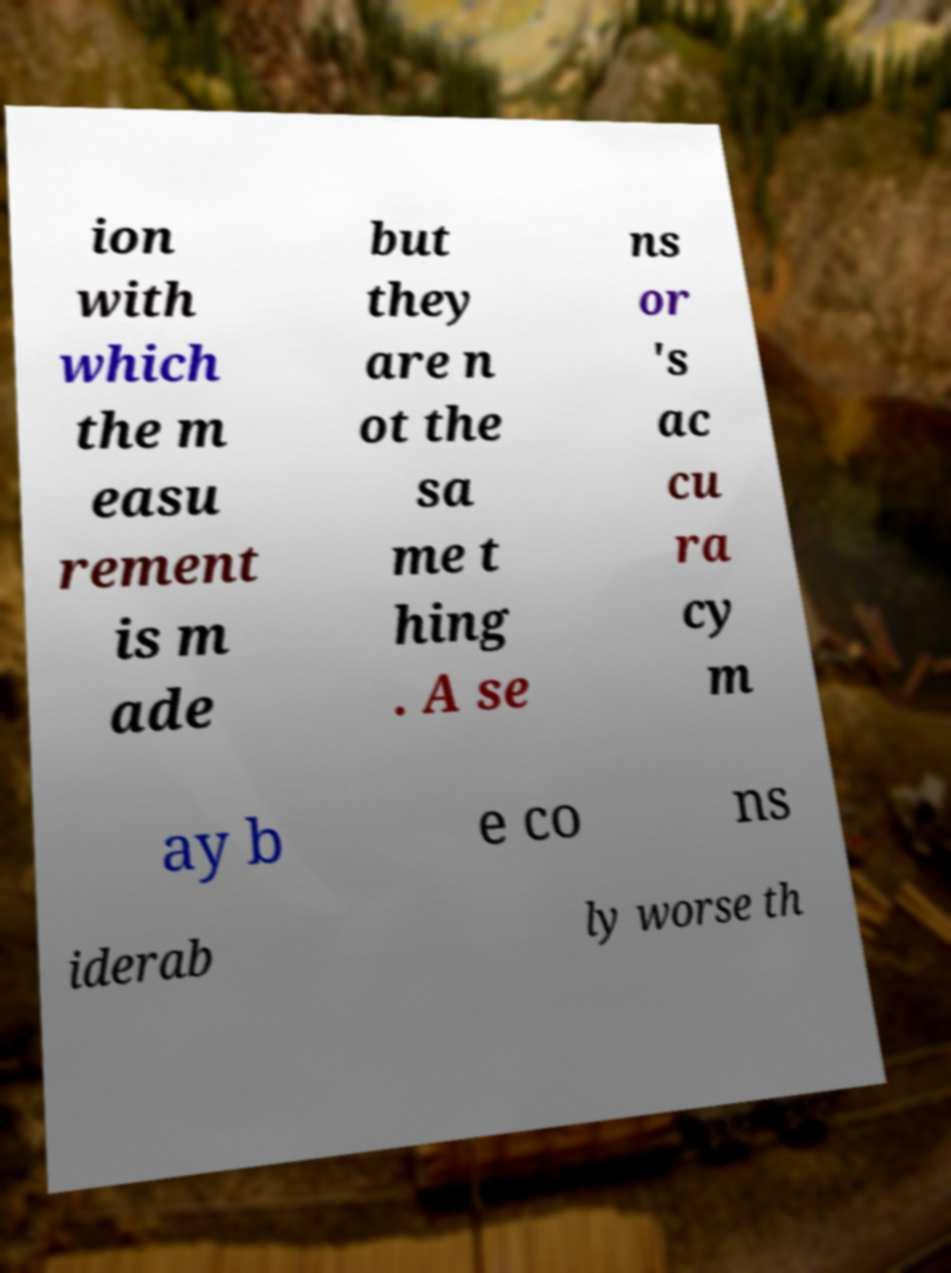What messages or text are displayed in this image? I need them in a readable, typed format. ion with which the m easu rement is m ade but they are n ot the sa me t hing . A se ns or 's ac cu ra cy m ay b e co ns iderab ly worse th 